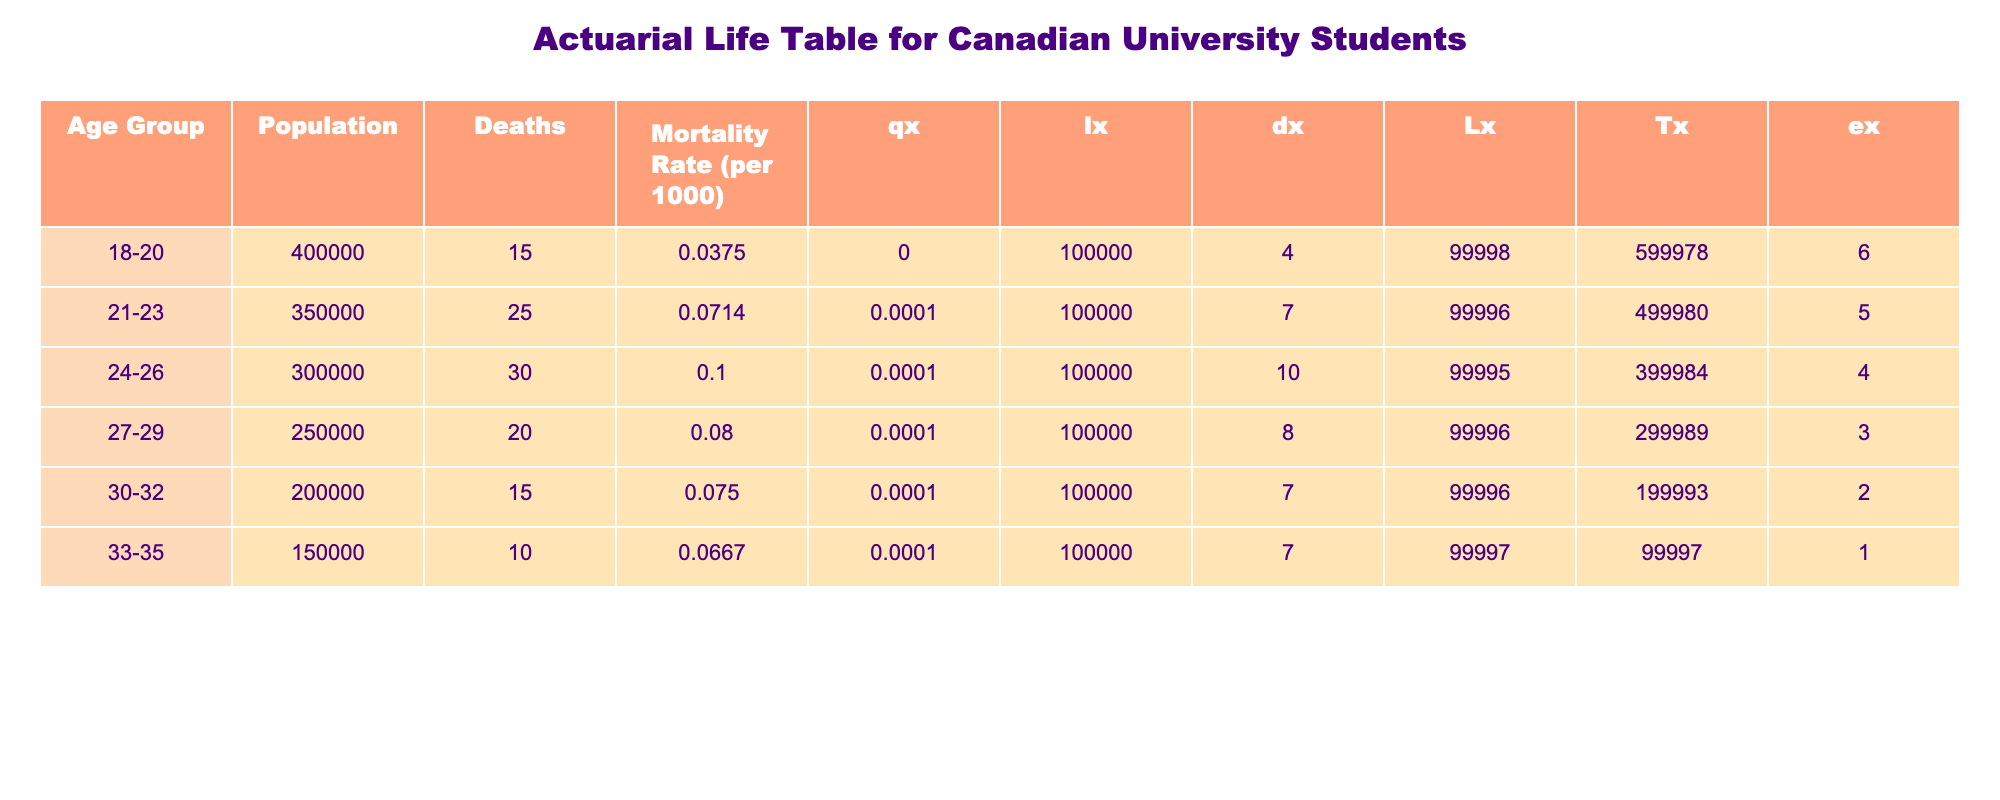What is the mortality rate for the age group 24-26? The table indicates the mortality rate for the age group 24-26 directly in the "Mortality Rate (per 1000)" column. Looking at the corresponding row for 24-26, the mortality rate is listed as 0.1000 per 1000.
Answer: 0.1000 per 1000 How many deaths occurred in the age group 21-23? The number of deaths is provided in the "Deaths" column specifically for the 21-23 age group. By checking the corresponding row, we find that 25 deaths occurred in this group.
Answer: 25 Which age group has the highest mortality rate? To find the highest mortality rate, we compare the values in the "Mortality Rate (per 1000)" column across all age groups. The highest value is 0.1000 for the age group 24-26.
Answer: 24-26 What is the total population of all age groups combined? By adding the populations in the "Population" column for each age group, we sum them up: 400000 + 350000 + 300000 + 250000 + 200000 + 150000 = 1950000.
Answer: 1950000 Is the mortality rate for the age group 30-32 higher than the rate for the age group 33-35? We need to compare the mortality rates in the "Mortality Rate (per 1000)" column for 30-32 and 33-35 age groups. The rate for 30-32 is 0.0750, and for 33-35 it is 0.0667. Since 0.0750 is greater than 0.0667, the answer is yes.
Answer: Yes What is the average mortality rate for the age groups 27-29 and 30-32 combined? First, we note the mortality rates for 27-29 (0.0800) and 30-32 (0.0750). To find the average, we sum these two rates: 0.0800 + 0.0750 = 0.1550, and then divide by 2 to get the average: 0.1550 / 2 = 0.0775.
Answer: 0.0775 Which age group has the fewest deaths recorded? By examining the "Deaths" column, we identify the age group with the lowest number. The age group 33-35 has 10 deaths, which is fewer than all others listed.
Answer: 33-35 If the population of the age group 18-20 were to increase by 10%, what would the new population be? The current population for the age group 18-20 is 400000. A 10% increase would mean we calculate 400000 * 0.10 = 40000, and then add that to the original population: 400000 + 40000 = 440000.
Answer: 440000 What is the total number of deaths for all age groups combined? We find the total deaths by summing up the values in the "Deaths" column: 15 + 25 + 30 + 20 + 15 + 10 = 115.
Answer: 115 Which age group has a mortality rate of 0.0667 or less? We check the "Mortality Rate (per 1000)" for each age group. The age groups with rates of 0.0667 or less are 33-35 (0.0667), 30-32 (0.0750), 27-29 (0.0800), and 18-20 (0.0375). Therefore, 33-35 qualifies.
Answer: 33-35, 30-32, 27-29, 18-20 